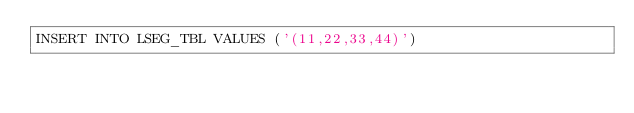Convert code to text. <code><loc_0><loc_0><loc_500><loc_500><_SQL_>INSERT INTO LSEG_TBL VALUES ('(11,22,33,44)')
</code> 